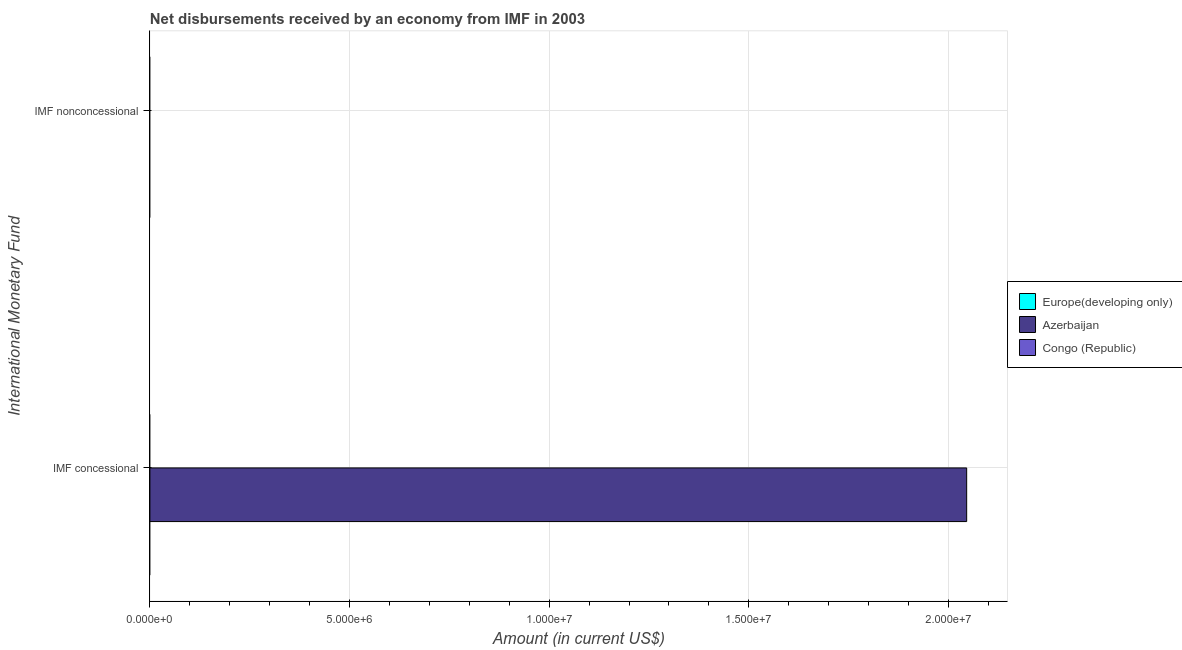Are the number of bars per tick equal to the number of legend labels?
Your response must be concise. No. How many bars are there on the 2nd tick from the top?
Your answer should be compact. 1. What is the label of the 1st group of bars from the top?
Your answer should be very brief. IMF nonconcessional. Across all countries, what is the maximum net concessional disbursements from imf?
Provide a short and direct response. 2.05e+07. In which country was the net concessional disbursements from imf maximum?
Offer a terse response. Azerbaijan. What is the total net concessional disbursements from imf in the graph?
Your answer should be compact. 2.05e+07. What is the difference between the net concessional disbursements from imf in Congo (Republic) and the net non concessional disbursements from imf in Azerbaijan?
Offer a very short reply. 0. In how many countries, is the net non concessional disbursements from imf greater than 17000000 US$?
Your answer should be very brief. 0. How many bars are there?
Provide a short and direct response. 1. What is the difference between two consecutive major ticks on the X-axis?
Give a very brief answer. 5.00e+06. Are the values on the major ticks of X-axis written in scientific E-notation?
Make the answer very short. Yes. Does the graph contain any zero values?
Provide a succinct answer. Yes. Does the graph contain grids?
Ensure brevity in your answer.  Yes. How many legend labels are there?
Make the answer very short. 3. What is the title of the graph?
Your answer should be very brief. Net disbursements received by an economy from IMF in 2003. What is the label or title of the X-axis?
Provide a succinct answer. Amount (in current US$). What is the label or title of the Y-axis?
Provide a short and direct response. International Monetary Fund. What is the Amount (in current US$) in Azerbaijan in IMF concessional?
Make the answer very short. 2.05e+07. Across all International Monetary Fund, what is the maximum Amount (in current US$) in Azerbaijan?
Keep it short and to the point. 2.05e+07. What is the total Amount (in current US$) of Azerbaijan in the graph?
Provide a succinct answer. 2.05e+07. What is the average Amount (in current US$) in Azerbaijan per International Monetary Fund?
Provide a short and direct response. 1.02e+07. What is the difference between the highest and the lowest Amount (in current US$) of Azerbaijan?
Ensure brevity in your answer.  2.05e+07. 